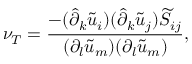Convert formula to latex. <formula><loc_0><loc_0><loc_500><loc_500>\nu _ { T } = \frac { - ( \hat { \partial } _ { k } \widetilde { u } _ { i } ) ( \hat { \partial } _ { k } \widetilde { u } _ { j } ) \widetilde { S } _ { i j } } { ( \partial _ { l } \widetilde { u } _ { m } ) ( \partial _ { l } \widetilde { u } _ { m } ) } ,</formula> 